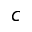<formula> <loc_0><loc_0><loc_500><loc_500>c</formula> 